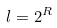<formula> <loc_0><loc_0><loc_500><loc_500>l = 2 ^ { R }</formula> 